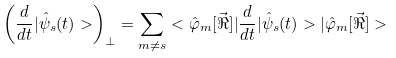Convert formula to latex. <formula><loc_0><loc_0><loc_500><loc_500>\left ( \frac { d } { d t } | \hat { \psi } _ { s } ( t ) > \right ) _ { \bot } = \sum _ { m \neq s } < \hat { \varphi } _ { m } [ \vec { \Re } ] | \frac { d } { d t } | \hat { \psi } _ { s } ( t ) > | \hat { \varphi } _ { m } [ \vec { \Re } ] ></formula> 